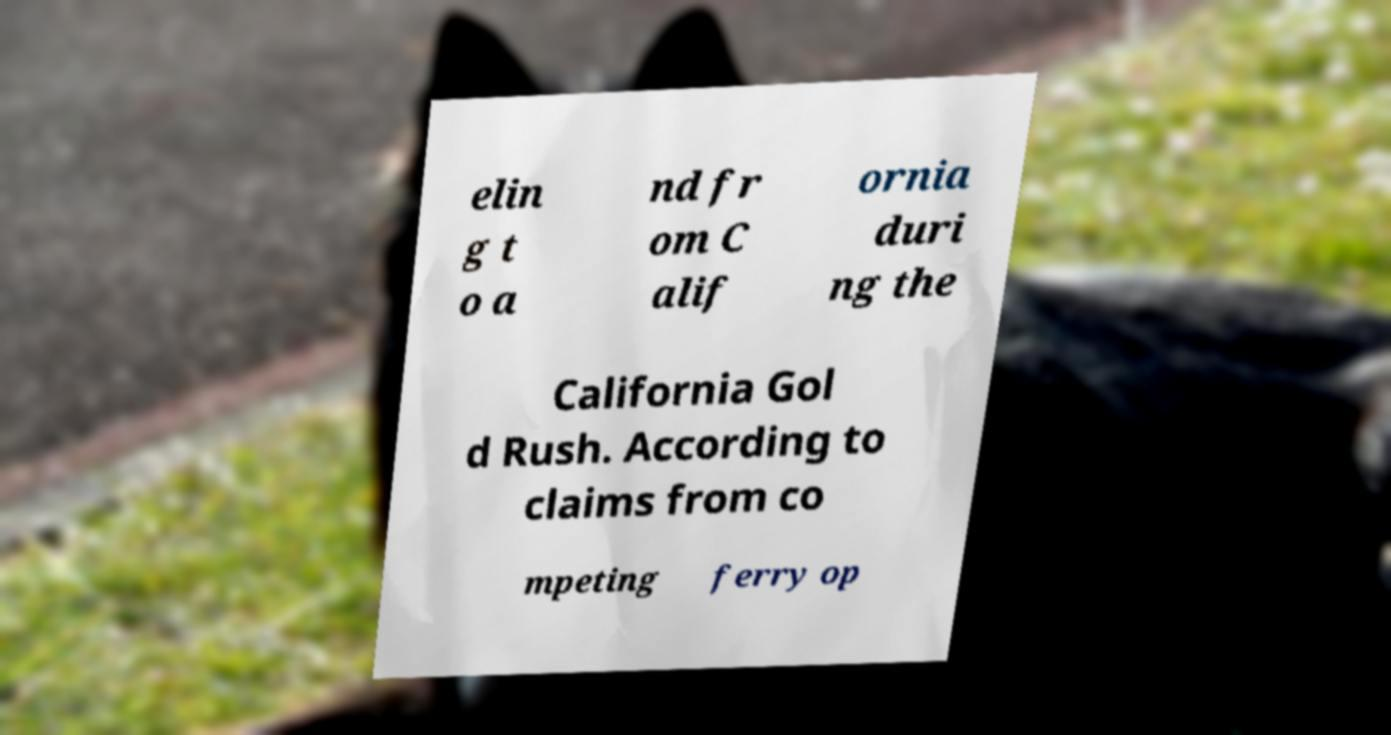Could you assist in decoding the text presented in this image and type it out clearly? elin g t o a nd fr om C alif ornia duri ng the California Gol d Rush. According to claims from co mpeting ferry op 